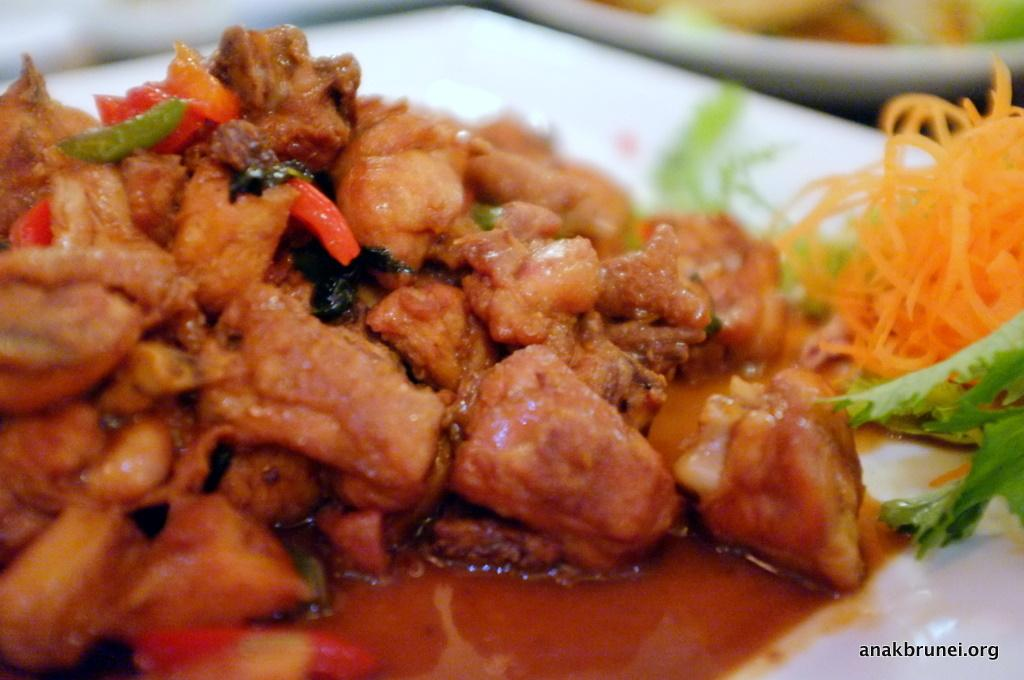What is present on the plates in the image? There are plates containing food in the image. Can you describe any additional text or information visible in the image? Yes, there is text visible in the bottom right corner of the image. What type of shock can be seen affecting the dolls in the image? There are no dolls present in the image, so there is no shock affecting any dolls. 